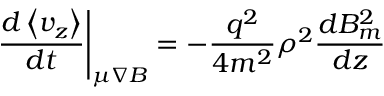<formula> <loc_0><loc_0><loc_500><loc_500>\frac { d \left \langle v _ { z } \right \rangle } { d t } \right | _ { \mu \nabla B } = - \frac { q ^ { 2 } } { 4 m ^ { 2 } } \rho ^ { 2 } \frac { d B _ { m } ^ { 2 } } { d z }</formula> 